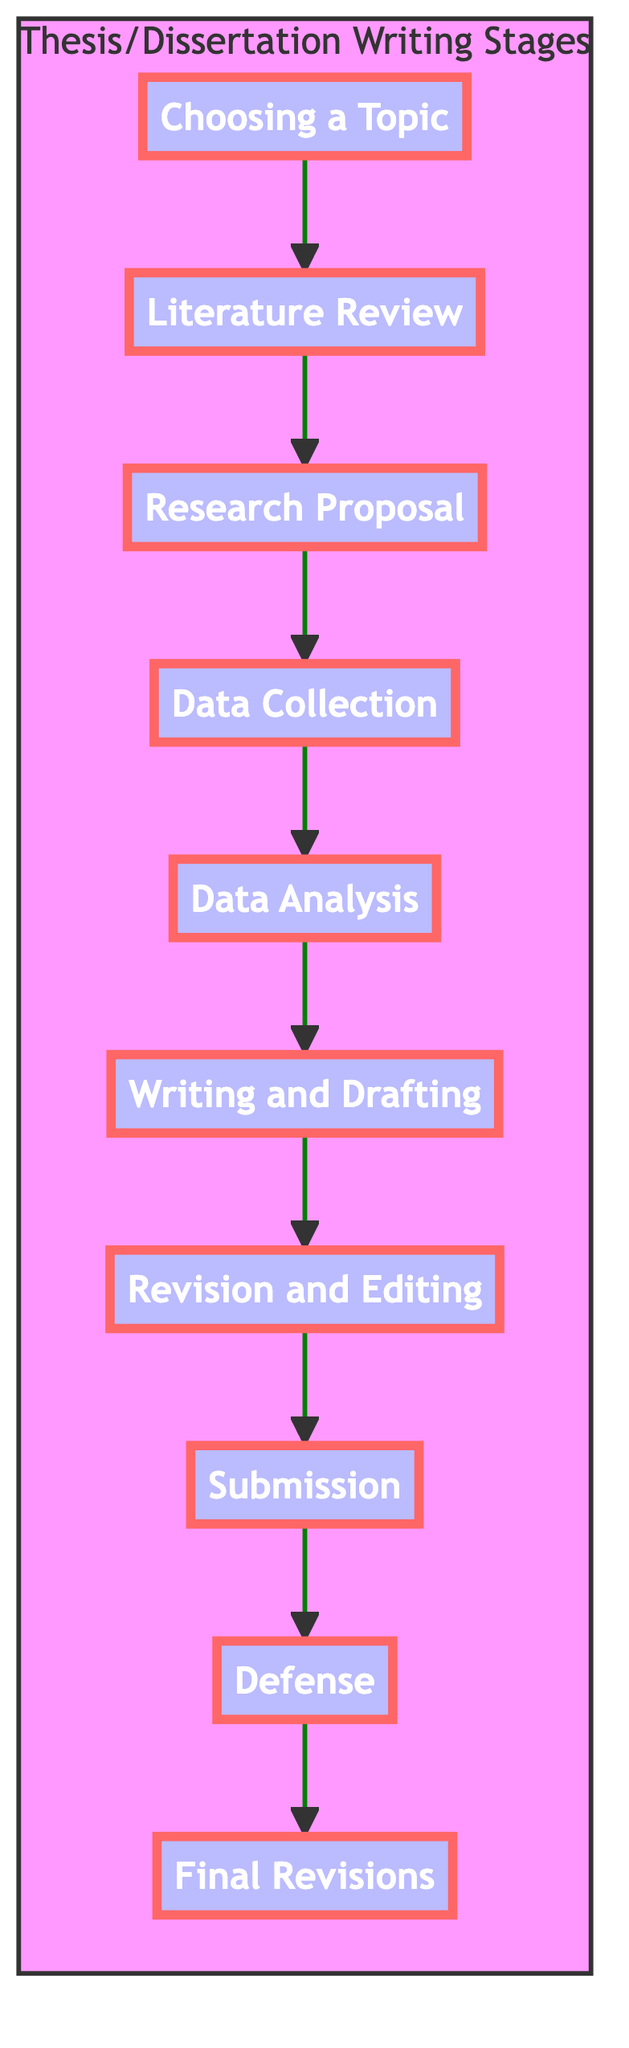What is the first stage of thesis writing? According to the diagram, the first stage is indicated as "Choosing a Topic." This is the starting point of the sequence outlined.
Answer: Choosing a Topic How many main stages are there in the diagram? By counting the nodes in the diagram, there are a total of ten stages or nodes from "Choosing a Topic" to "Final Revisions."
Answer: 10 What stage comes after the "Data Collection"? The flow chart shows that after "Data Collection," the next stage is "Data Analysis." This reflects the progression in the research process.
Answer: Data Analysis Which stage emphasizes the defense of research findings? The stage that emphasizes defending research findings is labeled as "Defense." This indicates a critical point in the thesis process where the student's work is presented to a committee.
Answer: Defense What is the final stage listed in the diagram? The diagram concludes with the "Final Revisions" stage, which is the last step after the defense where adjustments are made based on feedback.
Answer: Final Revisions Which two stages are directly connected by a single arrow? The connection occurs between "Literature Review" and "Research Proposal," indicating a direct progression from reviewing literature to proposing research.
Answer: Literature Review and Research Proposal What is required during the "Revision and Editing" stage? The "Revision and Editing" stage requires revising and refining the draft based on feedback. The focus is on improving clarity and coherence in the document.
Answer: Feedback based revisions What methods can be employed during "Data Collection"? The diagram notes that fieldwork, surveys, interviews, or archival research are methods used for data collection. This illustrates the variety of approaches available for gathering data.
Answer: Fieldwork, surveys, interviews, archival research Which stage involves writing a detailed proposal? The stage where a detailed proposal outlining the research plan is written is called "Research Proposal." This is essential for outlining the thesis objectives and methods.
Answer: Research Proposal What follows after "Writing and Drafting"? The stage that follows after "Writing and Drafting" is "Revision and Editing," indicating the next necessary step in finalizing the thesis document.
Answer: Revision and Editing 